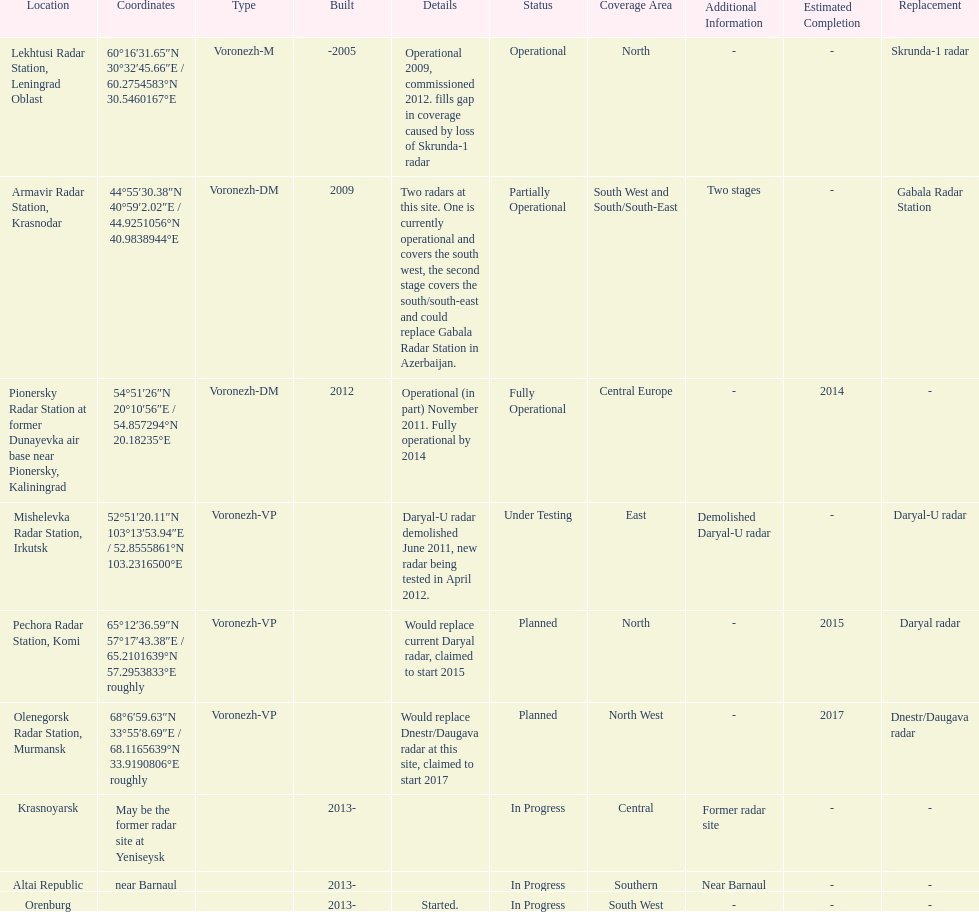What year built is at the top? -2005. 